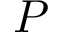Convert formula to latex. <formula><loc_0><loc_0><loc_500><loc_500>P</formula> 